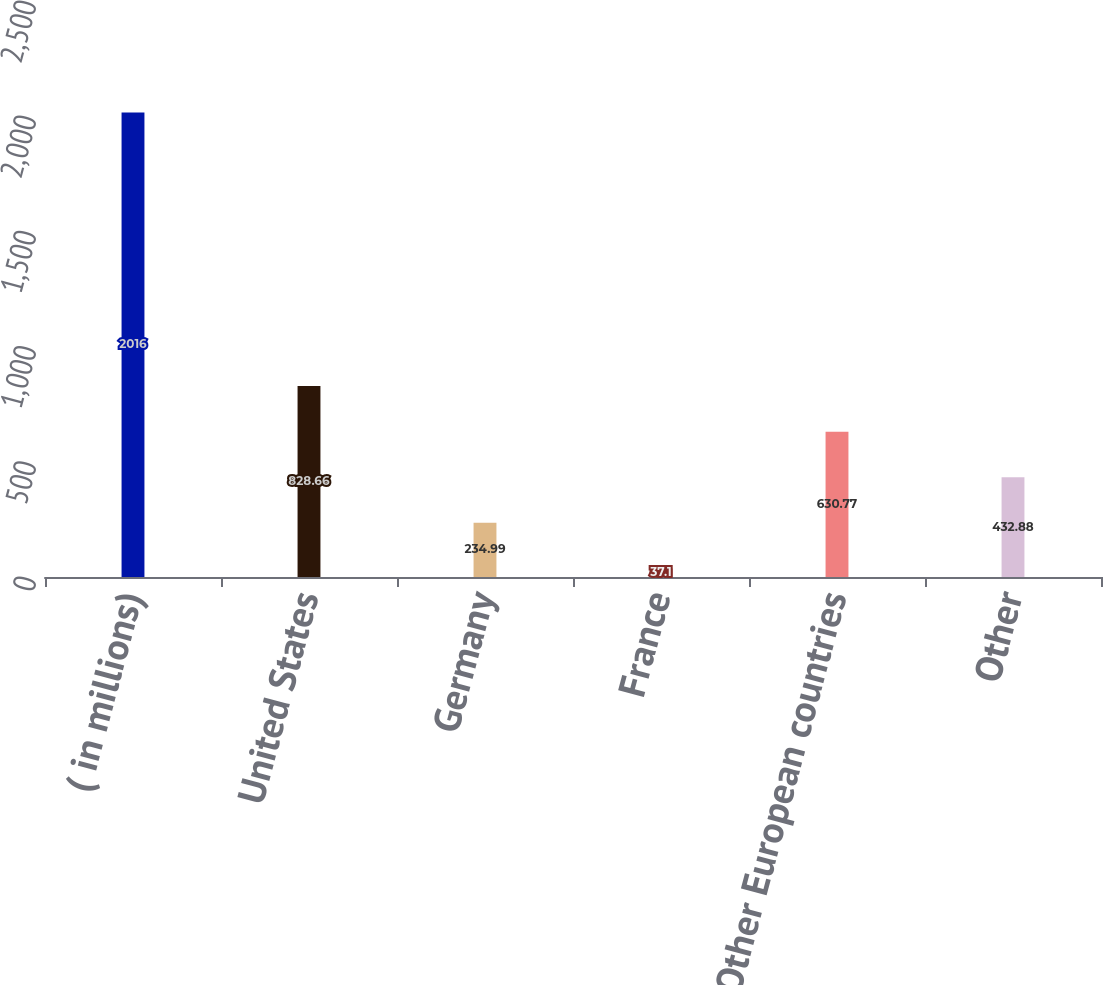Convert chart to OTSL. <chart><loc_0><loc_0><loc_500><loc_500><bar_chart><fcel>( in millions)<fcel>United States<fcel>Germany<fcel>France<fcel>Other European countries<fcel>Other<nl><fcel>2016<fcel>828.66<fcel>234.99<fcel>37.1<fcel>630.77<fcel>432.88<nl></chart> 